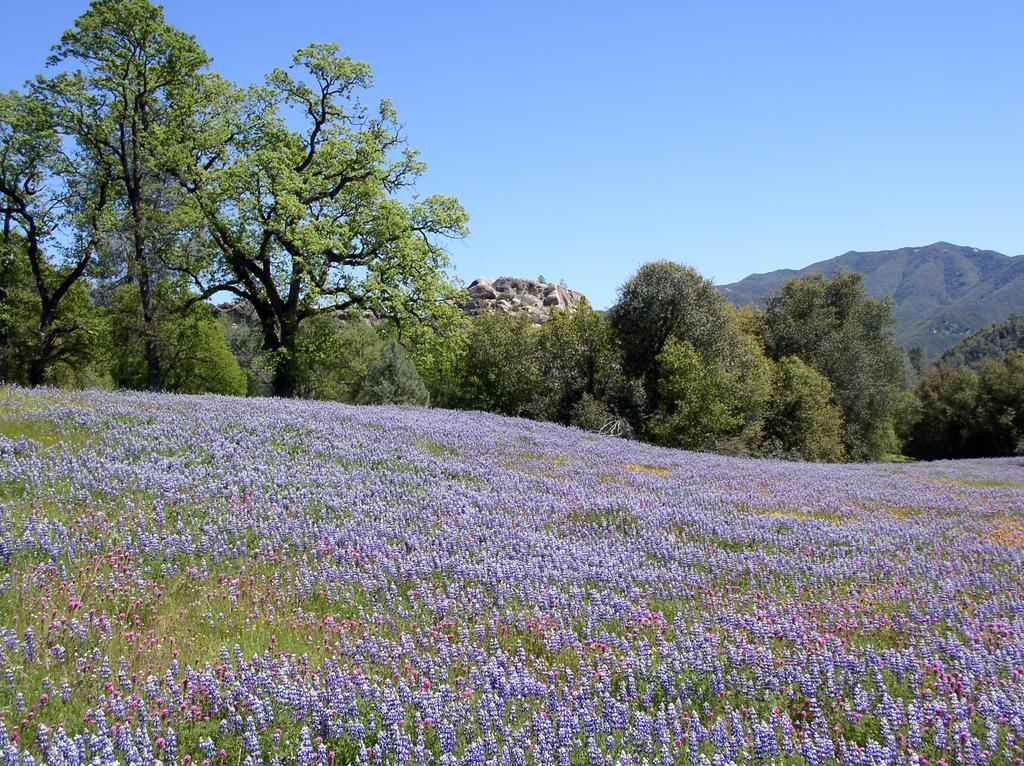What type of vegetation is at the bottom of the image? There are flowers at the bottom of the image. What can be seen in the background of the image? There are trees in the background of the image. What is visible at the top of the image? The sky is visible at the top of the image. What time is displayed on the clock in the image? There is no clock present in the image. What type of learning material is visible in the image? There is no learning material present in the image. What type of maid can be seen in the image? There is no maid present in the image. 